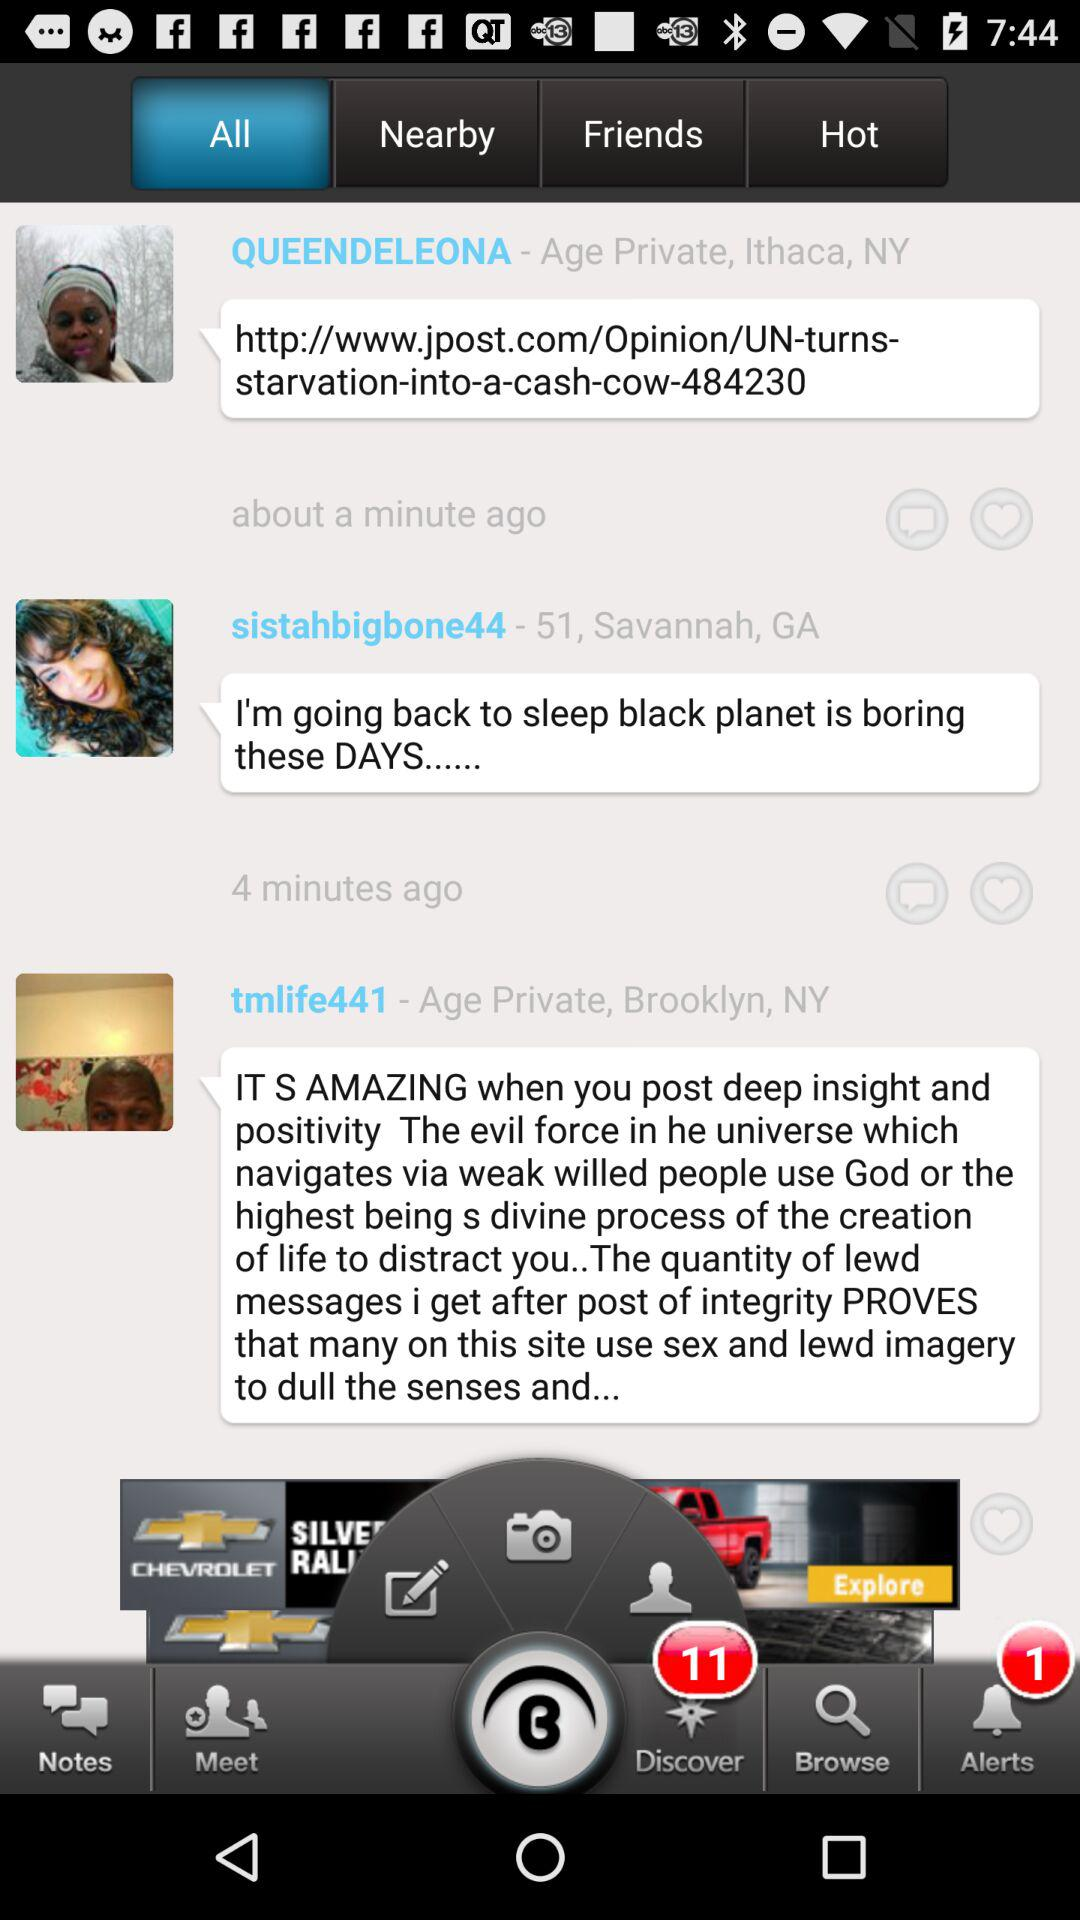Which tab is selected? The selected tab is "All". 